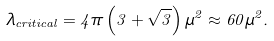Convert formula to latex. <formula><loc_0><loc_0><loc_500><loc_500>\lambda _ { c r i t i c a l } = 4 \pi \left ( 3 + \sqrt { 3 } \right ) \mu ^ { 2 } \approx 6 0 \mu ^ { 2 } .</formula> 